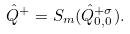<formula> <loc_0><loc_0><loc_500><loc_500>\hat { Q } ^ { + } = S _ { m } ( \hat { Q } ^ { + \sigma } _ { 0 , 0 } ) .</formula> 